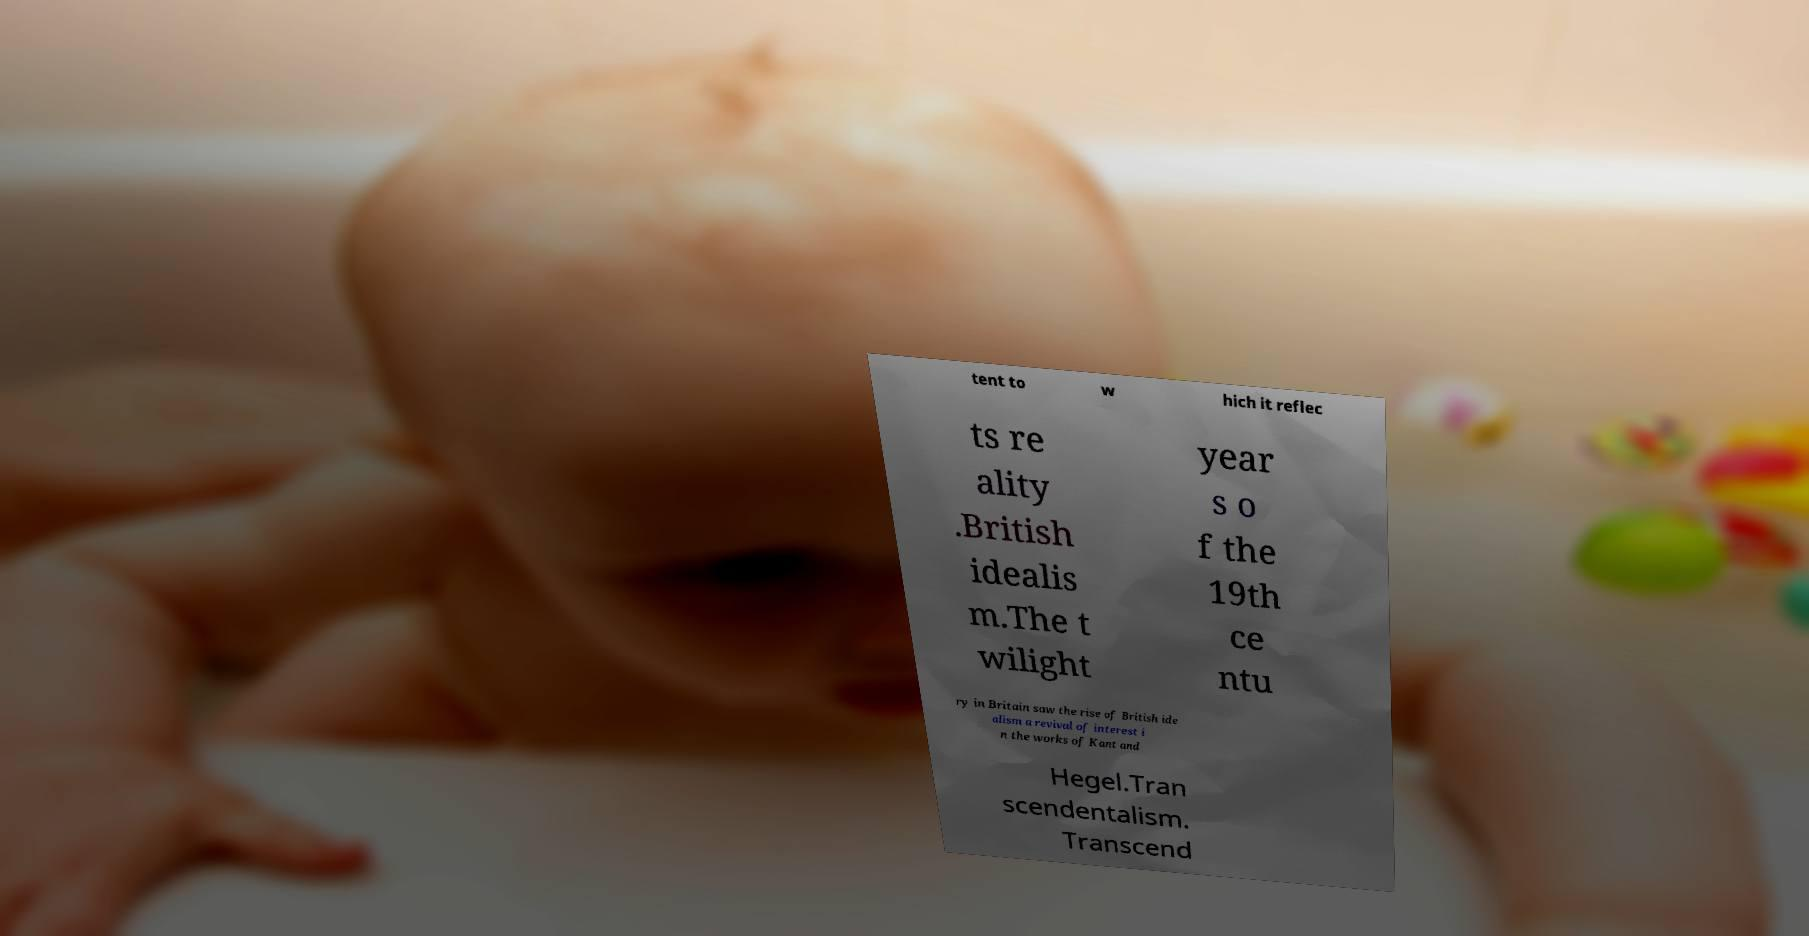For documentation purposes, I need the text within this image transcribed. Could you provide that? tent to w hich it reflec ts re ality .British idealis m.The t wilight year s o f the 19th ce ntu ry in Britain saw the rise of British ide alism a revival of interest i n the works of Kant and Hegel.Tran scendentalism. Transcend 